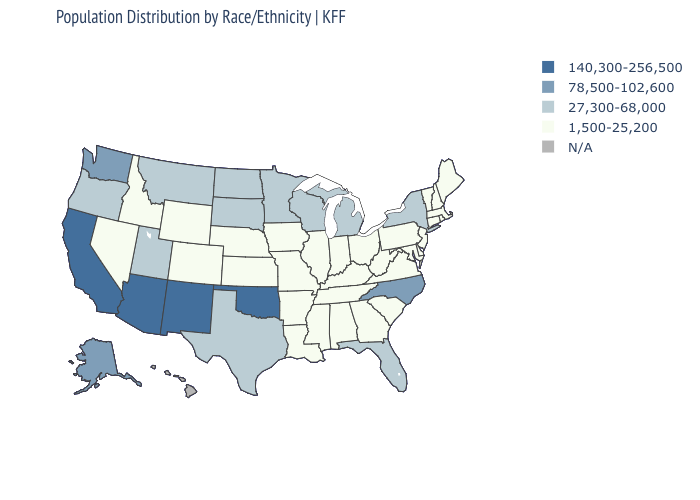Which states have the lowest value in the Northeast?
Answer briefly. Connecticut, Maine, Massachusetts, New Hampshire, New Jersey, Pennsylvania, Rhode Island, Vermont. What is the value of Nevada?
Quick response, please. 1,500-25,200. Name the states that have a value in the range 27,300-68,000?
Concise answer only. Florida, Michigan, Minnesota, Montana, New York, North Dakota, Oregon, South Dakota, Texas, Utah, Wisconsin. What is the value of Michigan?
Short answer required. 27,300-68,000. What is the value of Idaho?
Write a very short answer. 1,500-25,200. What is the value of Oklahoma?
Keep it brief. 140,300-256,500. What is the highest value in the MidWest ?
Give a very brief answer. 27,300-68,000. What is the value of New York?
Give a very brief answer. 27,300-68,000. Name the states that have a value in the range 1,500-25,200?
Give a very brief answer. Alabama, Arkansas, Colorado, Connecticut, Delaware, Georgia, Idaho, Illinois, Indiana, Iowa, Kansas, Kentucky, Louisiana, Maine, Maryland, Massachusetts, Mississippi, Missouri, Nebraska, Nevada, New Hampshire, New Jersey, Ohio, Pennsylvania, Rhode Island, South Carolina, Tennessee, Vermont, Virginia, West Virginia, Wyoming. Name the states that have a value in the range 78,500-102,600?
Short answer required. Alaska, North Carolina, Washington. What is the value of Minnesota?
Quick response, please. 27,300-68,000. Among the states that border New Mexico , which have the lowest value?
Keep it brief. Colorado. 